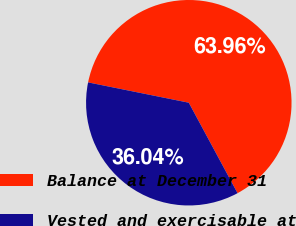<chart> <loc_0><loc_0><loc_500><loc_500><pie_chart><fcel>Balance at December 31<fcel>Vested and exercisable at<nl><fcel>63.96%<fcel>36.04%<nl></chart> 